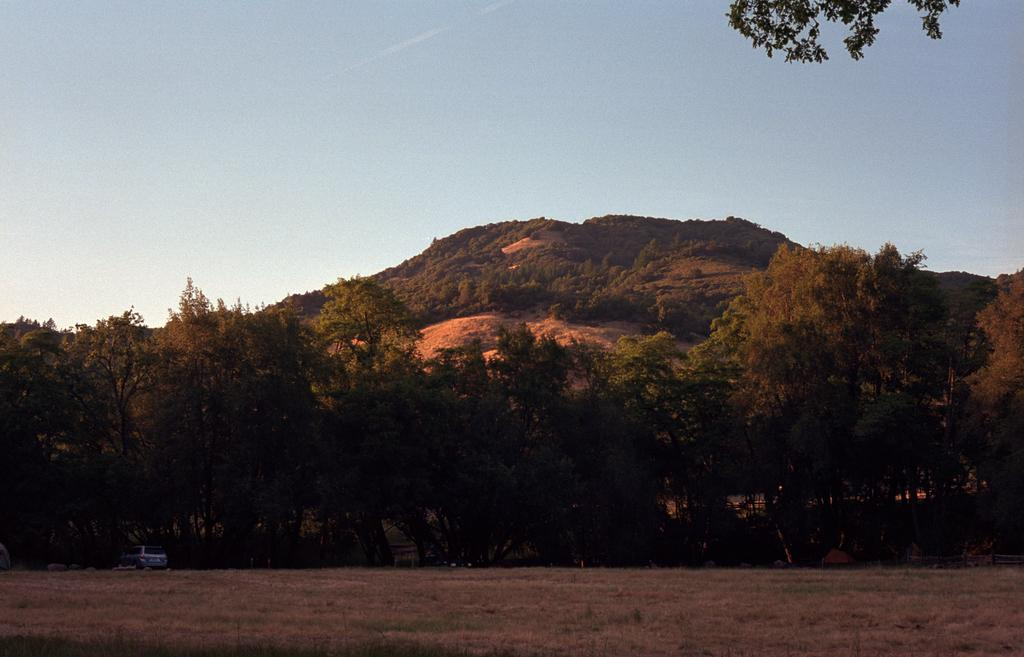What is the main subject of the image? There is a vehicle in the image. Can you describe the position of the vehicle? The vehicle is on the ground. What can be seen in the background of the image? There are trees and the sky visible in the background of the image. What color is the crayon used to draw the history of the vehicle in the image? There is no crayon or drawing of the vehicle's history present in the image. 